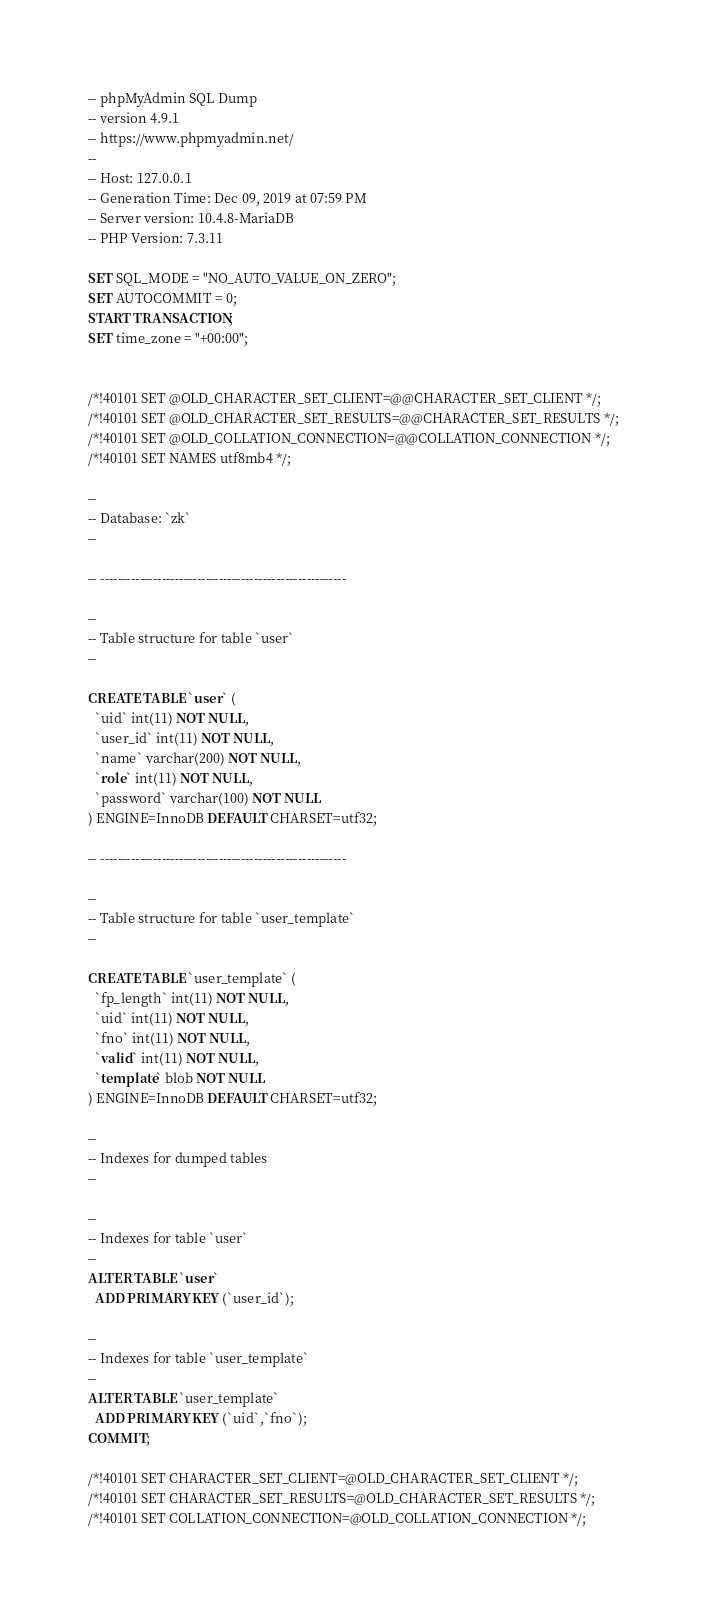Convert code to text. <code><loc_0><loc_0><loc_500><loc_500><_SQL_>-- phpMyAdmin SQL Dump
-- version 4.9.1
-- https://www.phpmyadmin.net/
--
-- Host: 127.0.0.1
-- Generation Time: Dec 09, 2019 at 07:59 PM
-- Server version: 10.4.8-MariaDB
-- PHP Version: 7.3.11

SET SQL_MODE = "NO_AUTO_VALUE_ON_ZERO";
SET AUTOCOMMIT = 0;
START TRANSACTION;
SET time_zone = "+00:00";


/*!40101 SET @OLD_CHARACTER_SET_CLIENT=@@CHARACTER_SET_CLIENT */;
/*!40101 SET @OLD_CHARACTER_SET_RESULTS=@@CHARACTER_SET_RESULTS */;
/*!40101 SET @OLD_COLLATION_CONNECTION=@@COLLATION_CONNECTION */;
/*!40101 SET NAMES utf8mb4 */;

--
-- Database: `zk`
--

-- --------------------------------------------------------

--
-- Table structure for table `user`
--

CREATE TABLE `user` (
  `uid` int(11) NOT NULL,
  `user_id` int(11) NOT NULL,
  `name` varchar(200) NOT NULL,
  `role` int(11) NOT NULL,
  `password` varchar(100) NOT NULL
) ENGINE=InnoDB DEFAULT CHARSET=utf32;

-- --------------------------------------------------------

--
-- Table structure for table `user_template`
--

CREATE TABLE `user_template` (
  `fp_length` int(11) NOT NULL,
  `uid` int(11) NOT NULL,
  `fno` int(11) NOT NULL,
  `valid` int(11) NOT NULL,
  `template` blob NOT NULL
) ENGINE=InnoDB DEFAULT CHARSET=utf32;

--
-- Indexes for dumped tables
--

--
-- Indexes for table `user`
--
ALTER TABLE `user`
  ADD PRIMARY KEY (`user_id`);

--
-- Indexes for table `user_template`
--
ALTER TABLE `user_template`
  ADD PRIMARY KEY (`uid`,`fno`);
COMMIT;

/*!40101 SET CHARACTER_SET_CLIENT=@OLD_CHARACTER_SET_CLIENT */;
/*!40101 SET CHARACTER_SET_RESULTS=@OLD_CHARACTER_SET_RESULTS */;
/*!40101 SET COLLATION_CONNECTION=@OLD_COLLATION_CONNECTION */;
</code> 